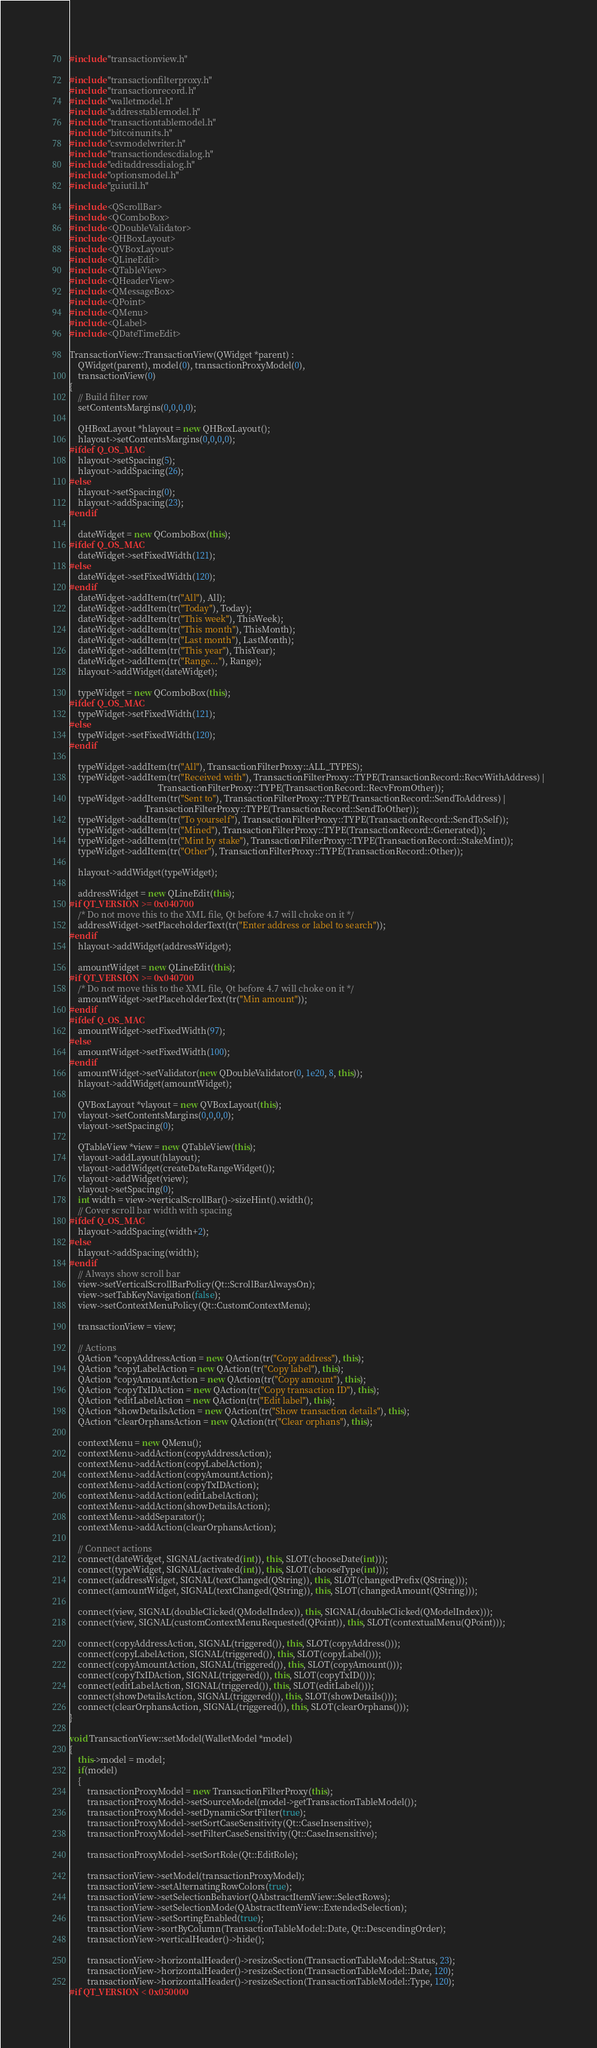<code> <loc_0><loc_0><loc_500><loc_500><_C++_>#include "transactionview.h"

#include "transactionfilterproxy.h"
#include "transactionrecord.h"
#include "walletmodel.h"
#include "addresstablemodel.h"
#include "transactiontablemodel.h"
#include "bitcoinunits.h"
#include "csvmodelwriter.h"
#include "transactiondescdialog.h"
#include "editaddressdialog.h"
#include "optionsmodel.h"
#include "guiutil.h"

#include <QScrollBar>
#include <QComboBox>
#include <QDoubleValidator>
#include <QHBoxLayout>
#include <QVBoxLayout>
#include <QLineEdit>
#include <QTableView>
#include <QHeaderView>
#include <QMessageBox>
#include <QPoint>
#include <QMenu>
#include <QLabel>
#include <QDateTimeEdit>

TransactionView::TransactionView(QWidget *parent) :
    QWidget(parent), model(0), transactionProxyModel(0),
    transactionView(0)
{
    // Build filter row
    setContentsMargins(0,0,0,0);

    QHBoxLayout *hlayout = new QHBoxLayout();
    hlayout->setContentsMargins(0,0,0,0);
#ifdef Q_OS_MAC
    hlayout->setSpacing(5);
    hlayout->addSpacing(26);
#else
    hlayout->setSpacing(0);
    hlayout->addSpacing(23);
#endif

    dateWidget = new QComboBox(this);
#ifdef Q_OS_MAC
    dateWidget->setFixedWidth(121);
#else
    dateWidget->setFixedWidth(120);
#endif
    dateWidget->addItem(tr("All"), All);
    dateWidget->addItem(tr("Today"), Today);
    dateWidget->addItem(tr("This week"), ThisWeek);
    dateWidget->addItem(tr("This month"), ThisMonth);
    dateWidget->addItem(tr("Last month"), LastMonth);
    dateWidget->addItem(tr("This year"), ThisYear);
    dateWidget->addItem(tr("Range..."), Range);
    hlayout->addWidget(dateWidget);

    typeWidget = new QComboBox(this);
#ifdef Q_OS_MAC
    typeWidget->setFixedWidth(121);
#else
    typeWidget->setFixedWidth(120);
#endif

    typeWidget->addItem(tr("All"), TransactionFilterProxy::ALL_TYPES);
    typeWidget->addItem(tr("Received with"), TransactionFilterProxy::TYPE(TransactionRecord::RecvWithAddress) |
                                        TransactionFilterProxy::TYPE(TransactionRecord::RecvFromOther));
    typeWidget->addItem(tr("Sent to"), TransactionFilterProxy::TYPE(TransactionRecord::SendToAddress) |
                                  TransactionFilterProxy::TYPE(TransactionRecord::SendToOther));
    typeWidget->addItem(tr("To yourself"), TransactionFilterProxy::TYPE(TransactionRecord::SendToSelf));
    typeWidget->addItem(tr("Mined"), TransactionFilterProxy::TYPE(TransactionRecord::Generated));
    typeWidget->addItem(tr("Mint by stake"), TransactionFilterProxy::TYPE(TransactionRecord::StakeMint));
    typeWidget->addItem(tr("Other"), TransactionFilterProxy::TYPE(TransactionRecord::Other));

    hlayout->addWidget(typeWidget);

    addressWidget = new QLineEdit(this);
#if QT_VERSION >= 0x040700
    /* Do not move this to the XML file, Qt before 4.7 will choke on it */
    addressWidget->setPlaceholderText(tr("Enter address or label to search"));
#endif
    hlayout->addWidget(addressWidget);

    amountWidget = new QLineEdit(this);
#if QT_VERSION >= 0x040700
    /* Do not move this to the XML file, Qt before 4.7 will choke on it */
    amountWidget->setPlaceholderText(tr("Min amount"));
#endif
#ifdef Q_OS_MAC
    amountWidget->setFixedWidth(97);
#else
    amountWidget->setFixedWidth(100);
#endif
    amountWidget->setValidator(new QDoubleValidator(0, 1e20, 8, this));
    hlayout->addWidget(amountWidget);

    QVBoxLayout *vlayout = new QVBoxLayout(this);
    vlayout->setContentsMargins(0,0,0,0);
    vlayout->setSpacing(0);

    QTableView *view = new QTableView(this);
    vlayout->addLayout(hlayout);
    vlayout->addWidget(createDateRangeWidget());
    vlayout->addWidget(view);
    vlayout->setSpacing(0);
    int width = view->verticalScrollBar()->sizeHint().width();
    // Cover scroll bar width with spacing
#ifdef Q_OS_MAC
    hlayout->addSpacing(width+2);
#else
    hlayout->addSpacing(width);
#endif
    // Always show scroll bar
    view->setVerticalScrollBarPolicy(Qt::ScrollBarAlwaysOn);
    view->setTabKeyNavigation(false);
    view->setContextMenuPolicy(Qt::CustomContextMenu);

    transactionView = view;

    // Actions
    QAction *copyAddressAction = new QAction(tr("Copy address"), this);
    QAction *copyLabelAction = new QAction(tr("Copy label"), this);
    QAction *copyAmountAction = new QAction(tr("Copy amount"), this);
    QAction *copyTxIDAction = new QAction(tr("Copy transaction ID"), this);
    QAction *editLabelAction = new QAction(tr("Edit label"), this);
    QAction *showDetailsAction = new QAction(tr("Show transaction details"), this);
    QAction *clearOrphansAction = new QAction(tr("Clear orphans"), this);

    contextMenu = new QMenu();
    contextMenu->addAction(copyAddressAction);
    contextMenu->addAction(copyLabelAction);
    contextMenu->addAction(copyAmountAction);
    contextMenu->addAction(copyTxIDAction);
    contextMenu->addAction(editLabelAction);
    contextMenu->addAction(showDetailsAction);
    contextMenu->addSeparator();
    contextMenu->addAction(clearOrphansAction);

    // Connect actions
    connect(dateWidget, SIGNAL(activated(int)), this, SLOT(chooseDate(int)));
    connect(typeWidget, SIGNAL(activated(int)), this, SLOT(chooseType(int)));
    connect(addressWidget, SIGNAL(textChanged(QString)), this, SLOT(changedPrefix(QString)));
    connect(amountWidget, SIGNAL(textChanged(QString)), this, SLOT(changedAmount(QString)));

    connect(view, SIGNAL(doubleClicked(QModelIndex)), this, SIGNAL(doubleClicked(QModelIndex)));
    connect(view, SIGNAL(customContextMenuRequested(QPoint)), this, SLOT(contextualMenu(QPoint)));

    connect(copyAddressAction, SIGNAL(triggered()), this, SLOT(copyAddress()));
    connect(copyLabelAction, SIGNAL(triggered()), this, SLOT(copyLabel()));
    connect(copyAmountAction, SIGNAL(triggered()), this, SLOT(copyAmount()));
    connect(copyTxIDAction, SIGNAL(triggered()), this, SLOT(copyTxID()));
    connect(editLabelAction, SIGNAL(triggered()), this, SLOT(editLabel()));
    connect(showDetailsAction, SIGNAL(triggered()), this, SLOT(showDetails()));
    connect(clearOrphansAction, SIGNAL(triggered()), this, SLOT(clearOrphans()));
}

void TransactionView::setModel(WalletModel *model)
{
    this->model = model;
    if(model)
    {
        transactionProxyModel = new TransactionFilterProxy(this);
        transactionProxyModel->setSourceModel(model->getTransactionTableModel());
        transactionProxyModel->setDynamicSortFilter(true);
        transactionProxyModel->setSortCaseSensitivity(Qt::CaseInsensitive);
        transactionProxyModel->setFilterCaseSensitivity(Qt::CaseInsensitive);

        transactionProxyModel->setSortRole(Qt::EditRole);

        transactionView->setModel(transactionProxyModel);
        transactionView->setAlternatingRowColors(true);
        transactionView->setSelectionBehavior(QAbstractItemView::SelectRows);
        transactionView->setSelectionMode(QAbstractItemView::ExtendedSelection);
        transactionView->setSortingEnabled(true);
        transactionView->sortByColumn(TransactionTableModel::Date, Qt::DescendingOrder);
        transactionView->verticalHeader()->hide();

        transactionView->horizontalHeader()->resizeSection(TransactionTableModel::Status, 23);
        transactionView->horizontalHeader()->resizeSection(TransactionTableModel::Date, 120);
        transactionView->horizontalHeader()->resizeSection(TransactionTableModel::Type, 120);
#if QT_VERSION < 0x050000</code> 